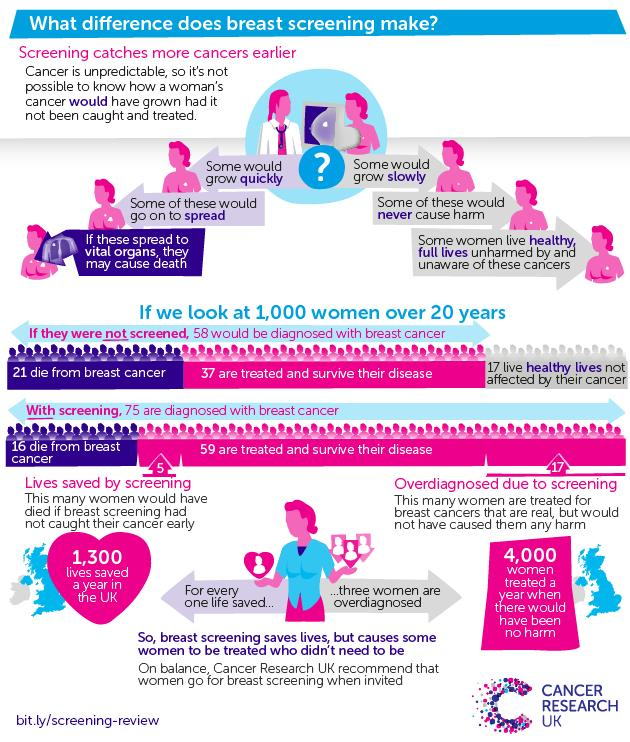Outline some significant characteristics in this image. Sixteen women have died as a result of breast cancer after undergoing screening. The screening of breast cancer has led to the recovery of 59 women who were previously diagnosed with the disease. Breast cancer screening can have the disadvantage of causing some women who do not have the disease to be treated, leading to unnecessary medical intervention. If all women were not screened for breast cancer, it is estimated that approximately 21 women would have died due to the disease. According to our data, a total of 4,000 women were treated for breast cancer, despite the fact that their lives were not at risk. 